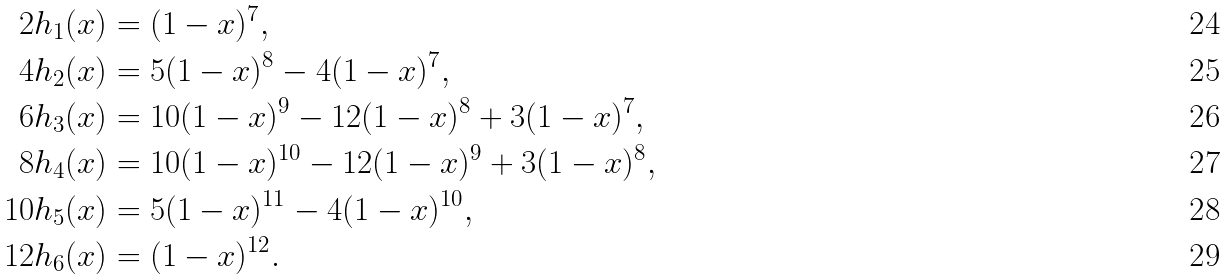<formula> <loc_0><loc_0><loc_500><loc_500>2 h _ { 1 } ( x ) & = ( 1 - x ) ^ { 7 } , \\ 4 h _ { 2 } ( x ) & = 5 ( 1 - x ) ^ { 8 } - 4 ( 1 - x ) ^ { 7 } , \\ 6 h _ { 3 } ( x ) & = 1 0 ( 1 - x ) ^ { 9 } - 1 2 ( 1 - x ) ^ { 8 } + 3 ( 1 - x ) ^ { 7 } , \\ 8 h _ { 4 } ( x ) & = 1 0 ( 1 - x ) ^ { 1 0 } - 1 2 ( 1 - x ) ^ { 9 } + 3 ( 1 - x ) ^ { 8 } , \\ 1 0 h _ { 5 } ( x ) & = 5 ( 1 - x ) ^ { 1 1 } - 4 ( 1 - x ) ^ { 1 0 } , \\ 1 2 h _ { 6 } ( x ) & = ( 1 - x ) ^ { 1 2 } .</formula> 